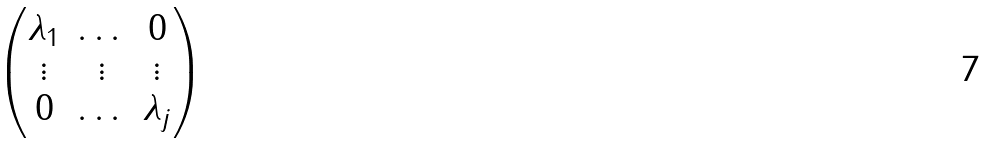Convert formula to latex. <formula><loc_0><loc_0><loc_500><loc_500>\begin{pmatrix} \lambda _ { 1 } & \dots & 0 \\ \vdots & \vdots & \vdots \\ 0 & \dots & \lambda _ { j } \\ \end{pmatrix}</formula> 